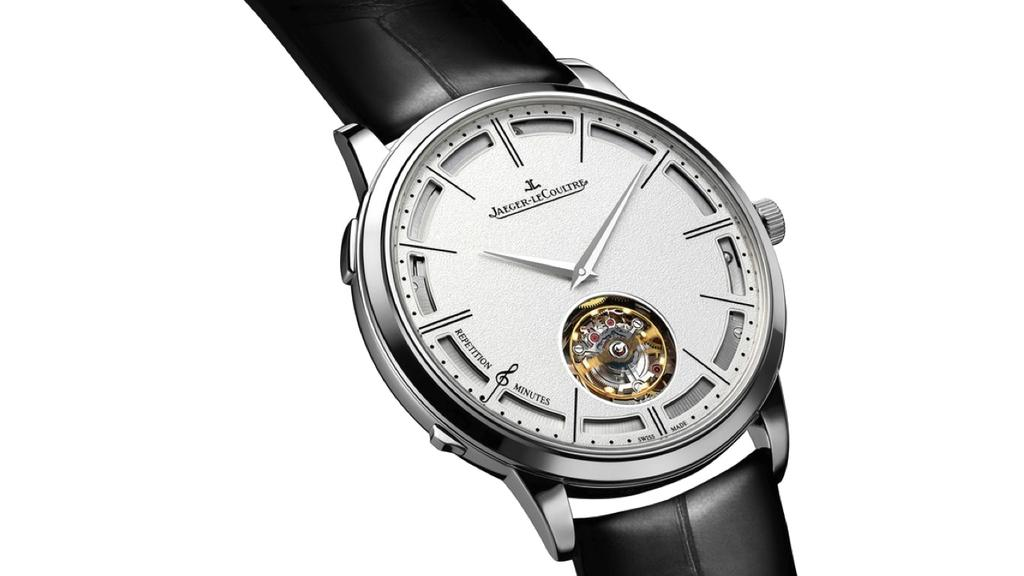Provide a one-sentence caption for the provided image. A Jaeger LeCoultre watch is shown with a black band. 